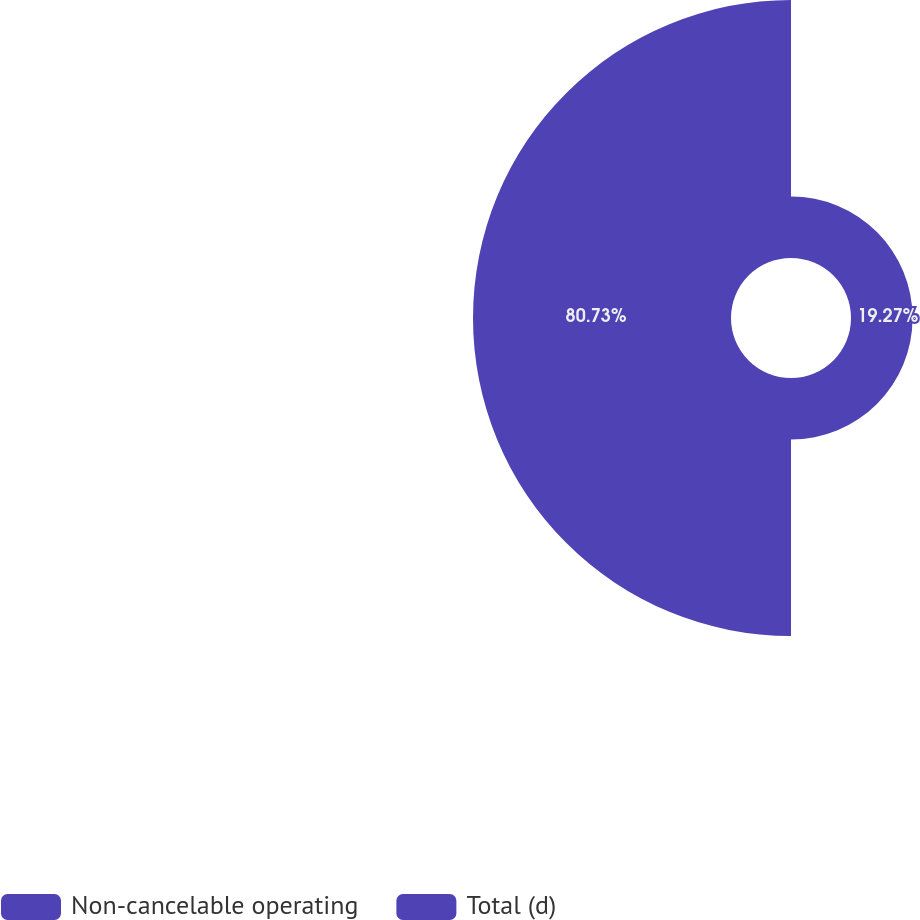<chart> <loc_0><loc_0><loc_500><loc_500><pie_chart><fcel>Non-cancelable operating<fcel>Total (d)<nl><fcel>19.27%<fcel>80.73%<nl></chart> 